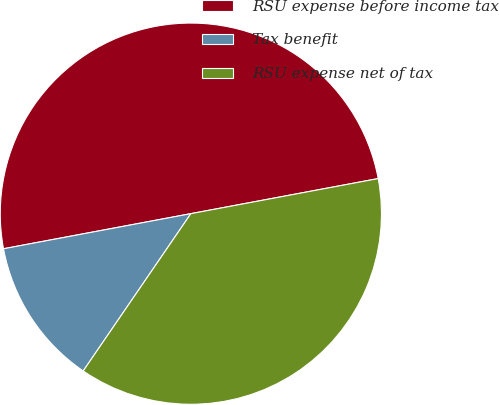Convert chart. <chart><loc_0><loc_0><loc_500><loc_500><pie_chart><fcel>RSU expense before income tax<fcel>Tax benefit<fcel>RSU expense net of tax<nl><fcel>50.0%<fcel>12.5%<fcel>37.5%<nl></chart> 